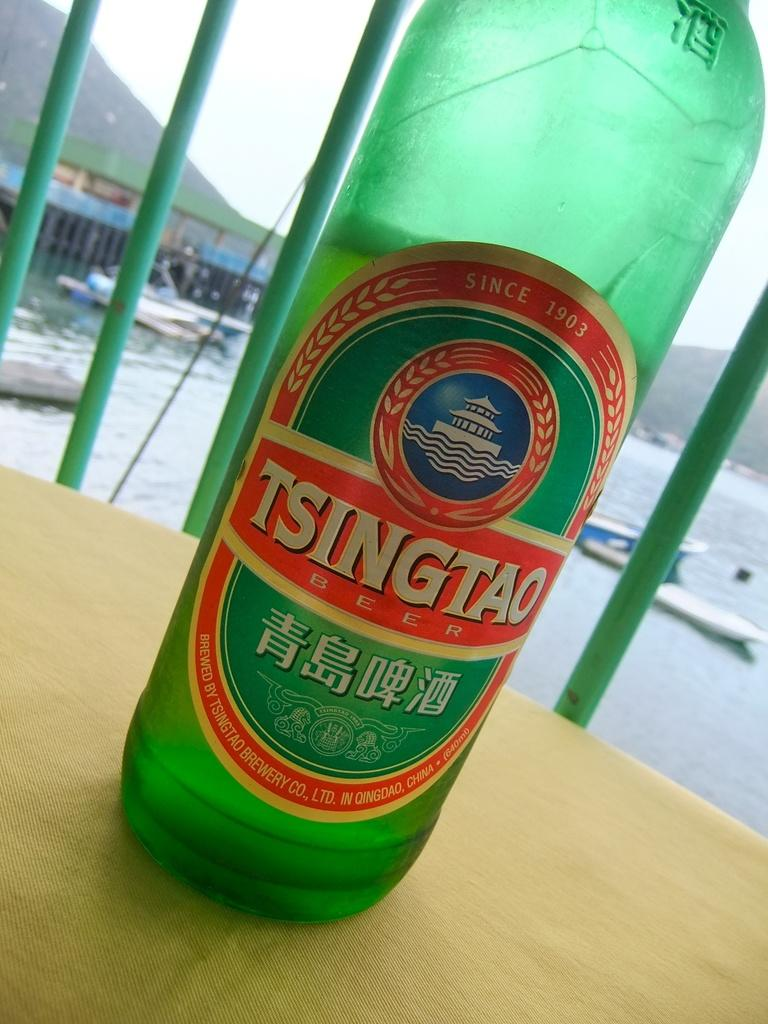<image>
Create a compact narrative representing the image presented. A bottle of Tsingtao beer sits on a harborside table. 